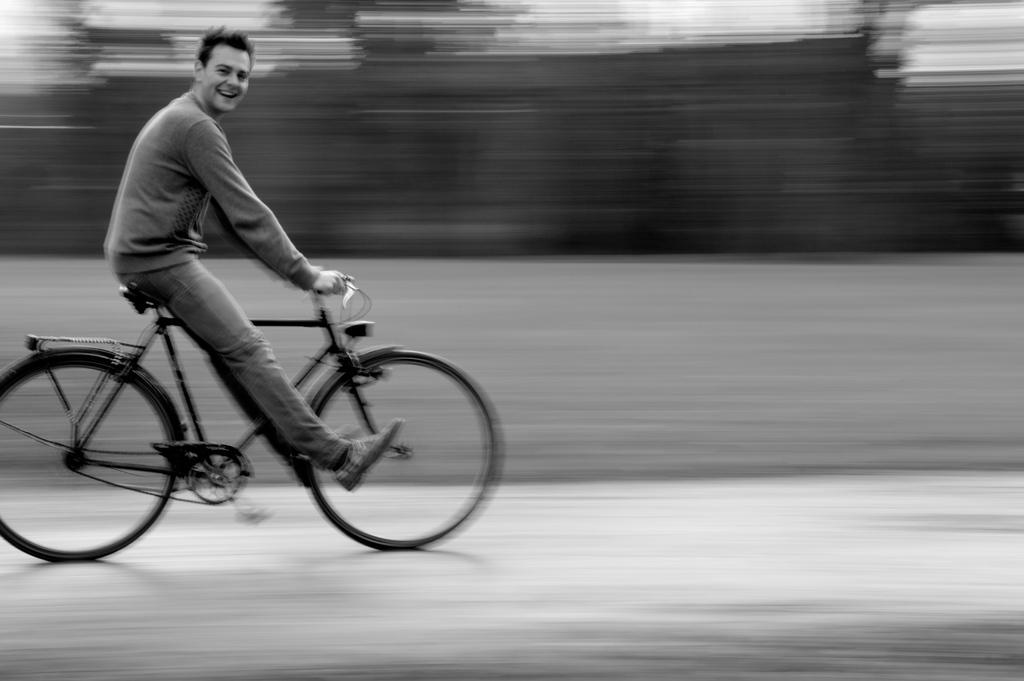Who is the main subject in the image? There is a man in the image. What is the man doing in the image? The man is riding a bicycle. How is the man controlling the bicycle? The man is holding a handle while riding the bicycle. What part of the bicycle is the man sitting on? The man is sitting on a seat while riding the bicycle. Can you describe the background of the image? The background of the image is blurry. What type of duck can be seen swimming in the background of the image? There is no duck present in the image; the background is blurry. How does the man's haircut look while riding the bicycle? The image does not show the man's haircut, so it cannot be determined from the image. 